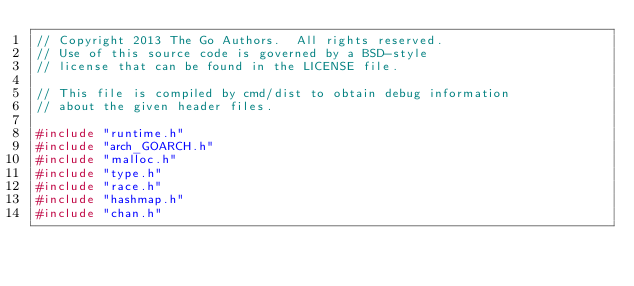<code> <loc_0><loc_0><loc_500><loc_500><_C_>// Copyright 2013 The Go Authors.  All rights reserved.
// Use of this source code is governed by a BSD-style
// license that can be found in the LICENSE file.

// This file is compiled by cmd/dist to obtain debug information
// about the given header files.

#include "runtime.h"
#include "arch_GOARCH.h"
#include "malloc.h"
#include "type.h"
#include "race.h"
#include "hashmap.h"
#include "chan.h"
</code> 